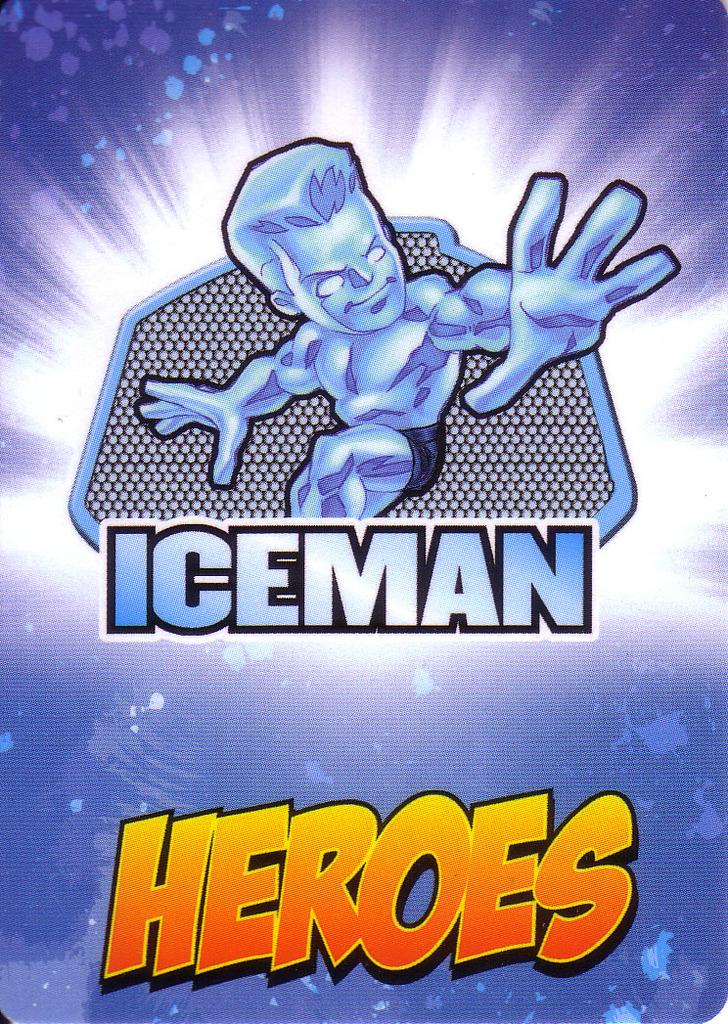What  is the name of the heroes?
Your answer should be very brief. Iceman. 